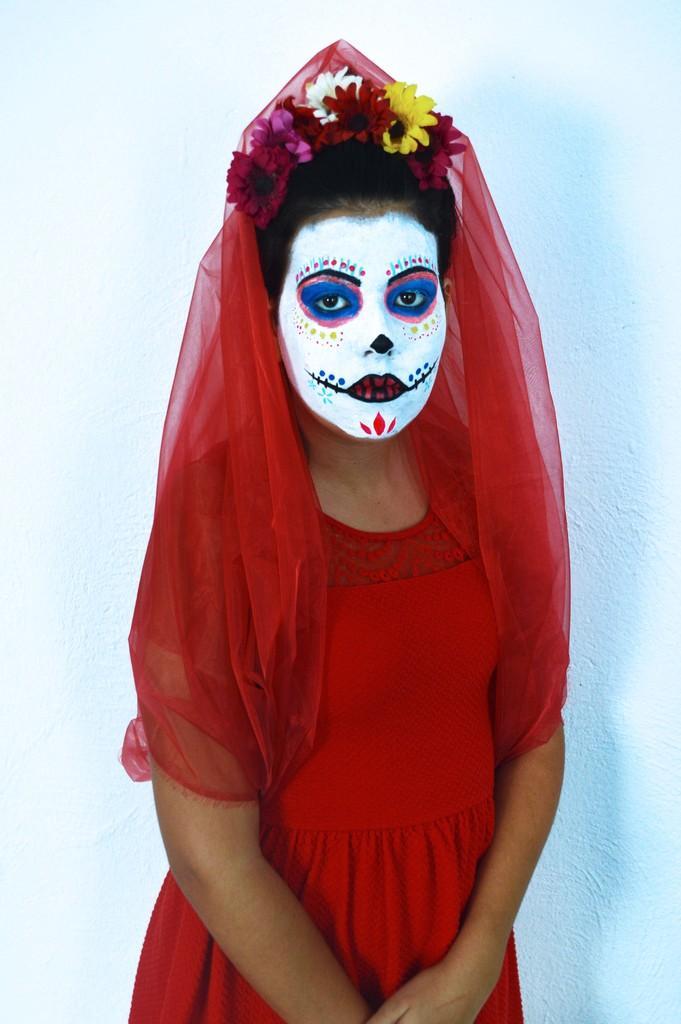In one or two sentences, can you explain what this image depicts? In this image, we can see a human is wearing red color costume. She wore a flower crown on her head. Background there is a white wall. 